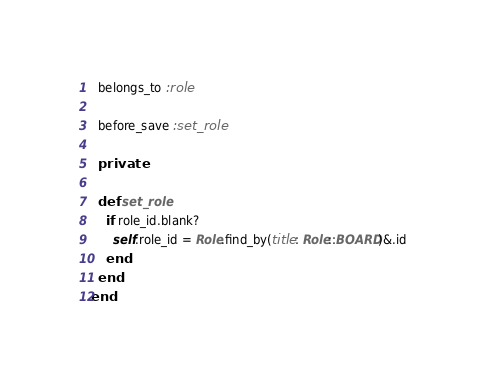<code> <loc_0><loc_0><loc_500><loc_500><_Ruby_>  belongs_to :role

  before_save :set_role

  private

  def set_role
    if role_id.blank?
      self.role_id = Role.find_by(title: Role::BOARD)&.id
    end
  end
end
</code> 